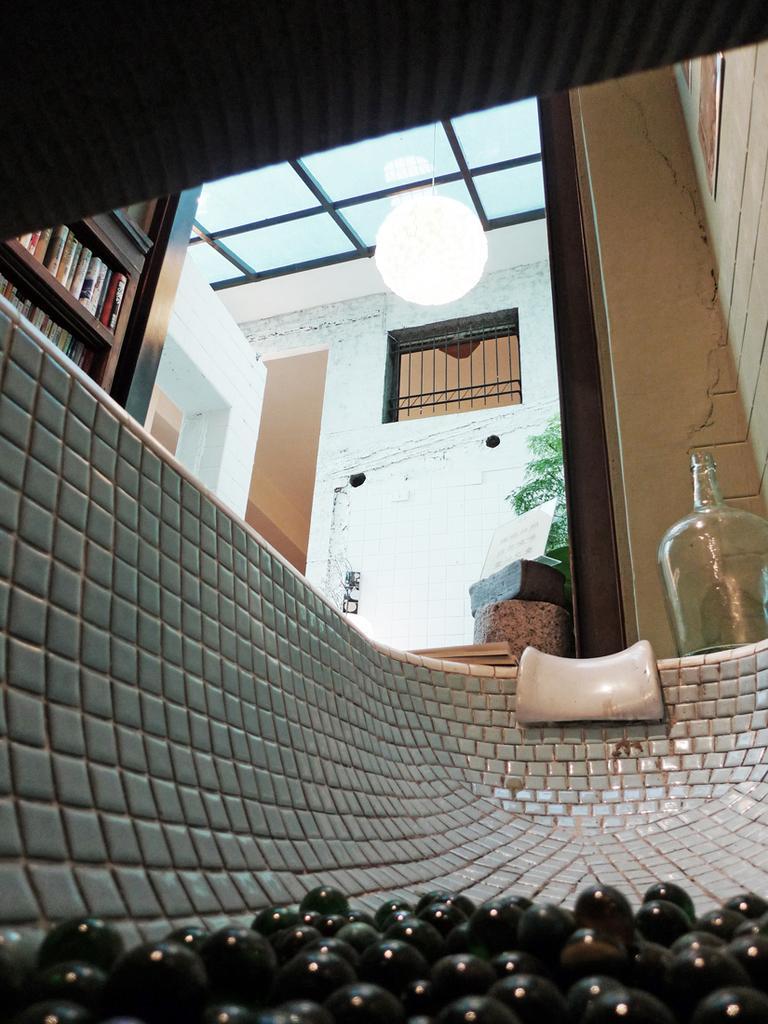Please provide a concise description of this image. In this image I see black balls in a tub, a jar and books over here. In the background I see the wall. 